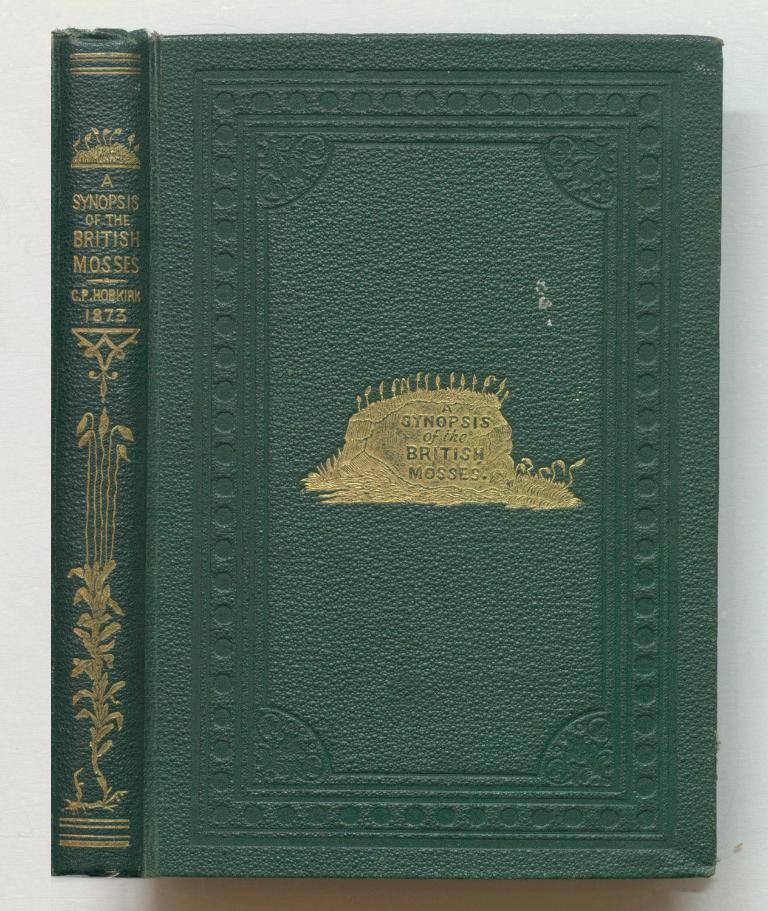<image>
Share a concise interpretation of the image provided. A Synopsis of the British Mosses sits open on a white table, with green leather binding. 